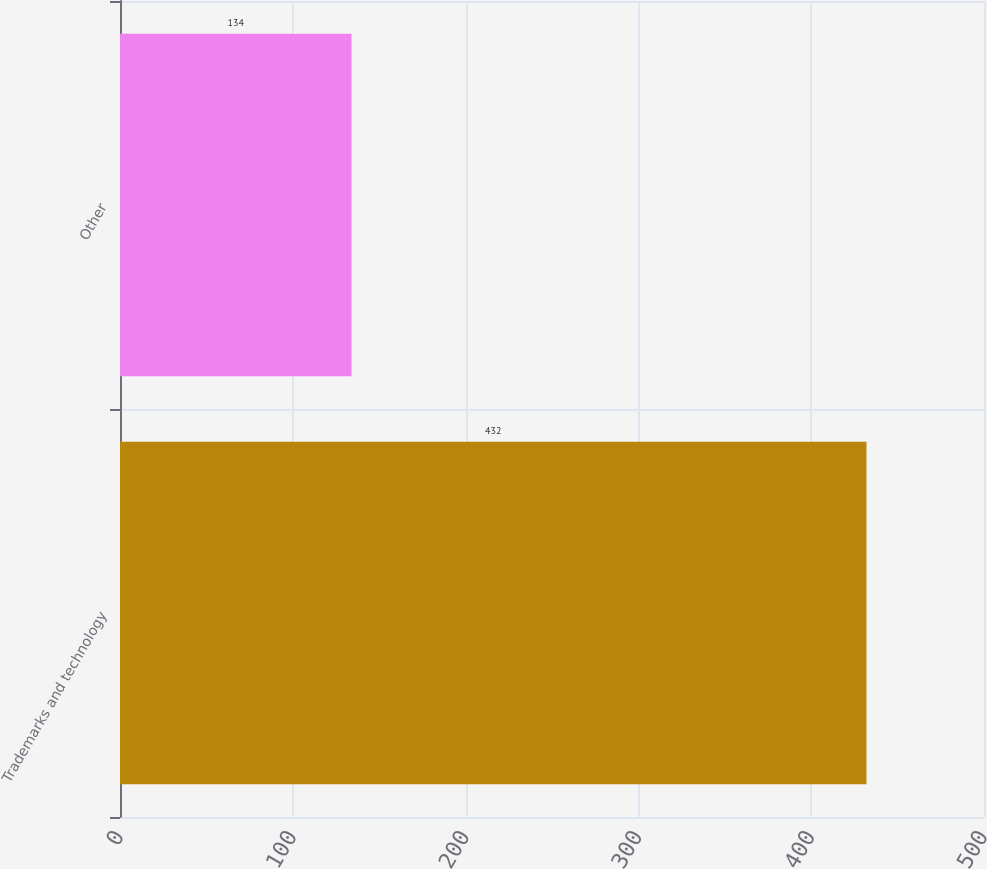Convert chart to OTSL. <chart><loc_0><loc_0><loc_500><loc_500><bar_chart><fcel>Trademarks and technology<fcel>Other<nl><fcel>432<fcel>134<nl></chart> 